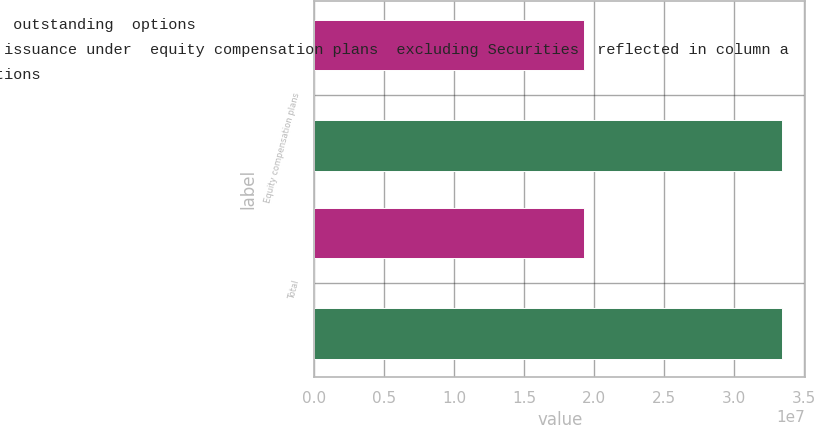<chart> <loc_0><loc_0><loc_500><loc_500><stacked_bar_chart><ecel><fcel>Equity compensation plans<fcel>Total<nl><fcel>a Number of  Securities to be  issued upon  exercise of  outstanding  options<fcel>1.93081e+07<fcel>1.93081e+07<nl><fcel>c Number of Securities  remaining available for  future issuance under  equity compensation plans  excluding Securities  reflected in column a<fcel>12.71<fcel>12.71<nl><fcel>b Weighted  average  exercise price  of outstanding  options<fcel>3.34424e+07<fcel>3.34424e+07<nl></chart> 